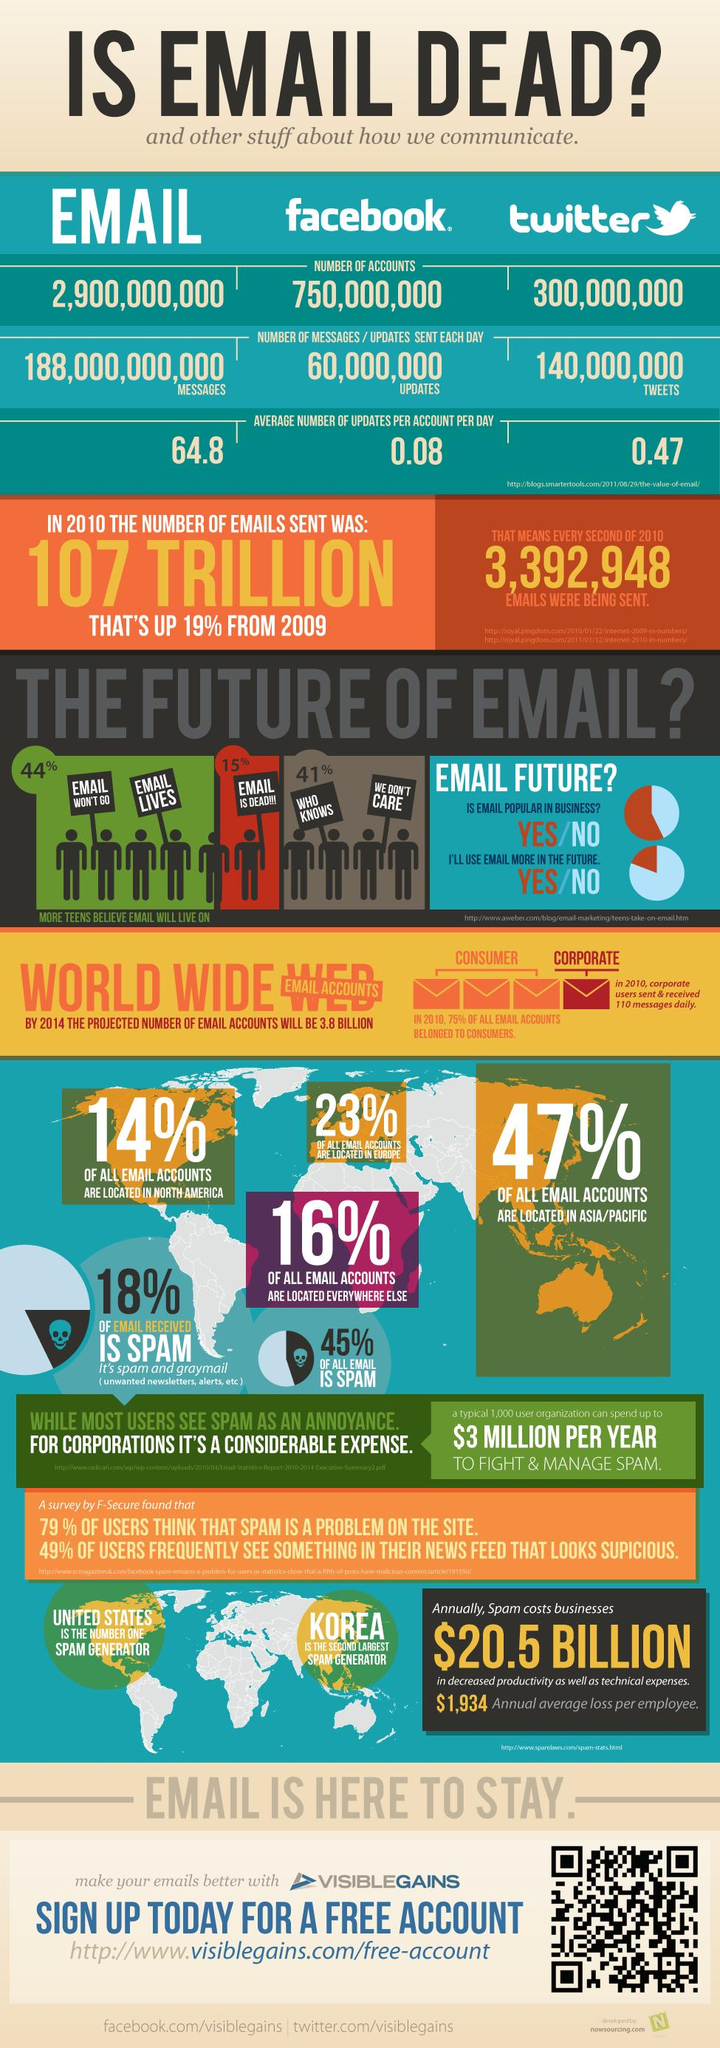Mention a couple of crucial points in this snapshot. According to a survey of teenagers, 44% believe that emails still exist. According to a recent survey, 15% of teenagers believe that emails are dead. According to recent statistics, approximately 45% of all emails worldwide are spam. There were approximately 60 million Facebook updates sent worldwide each day as of [insert date]. According to a recent survey, 41% of teenagers do not care about emails. 